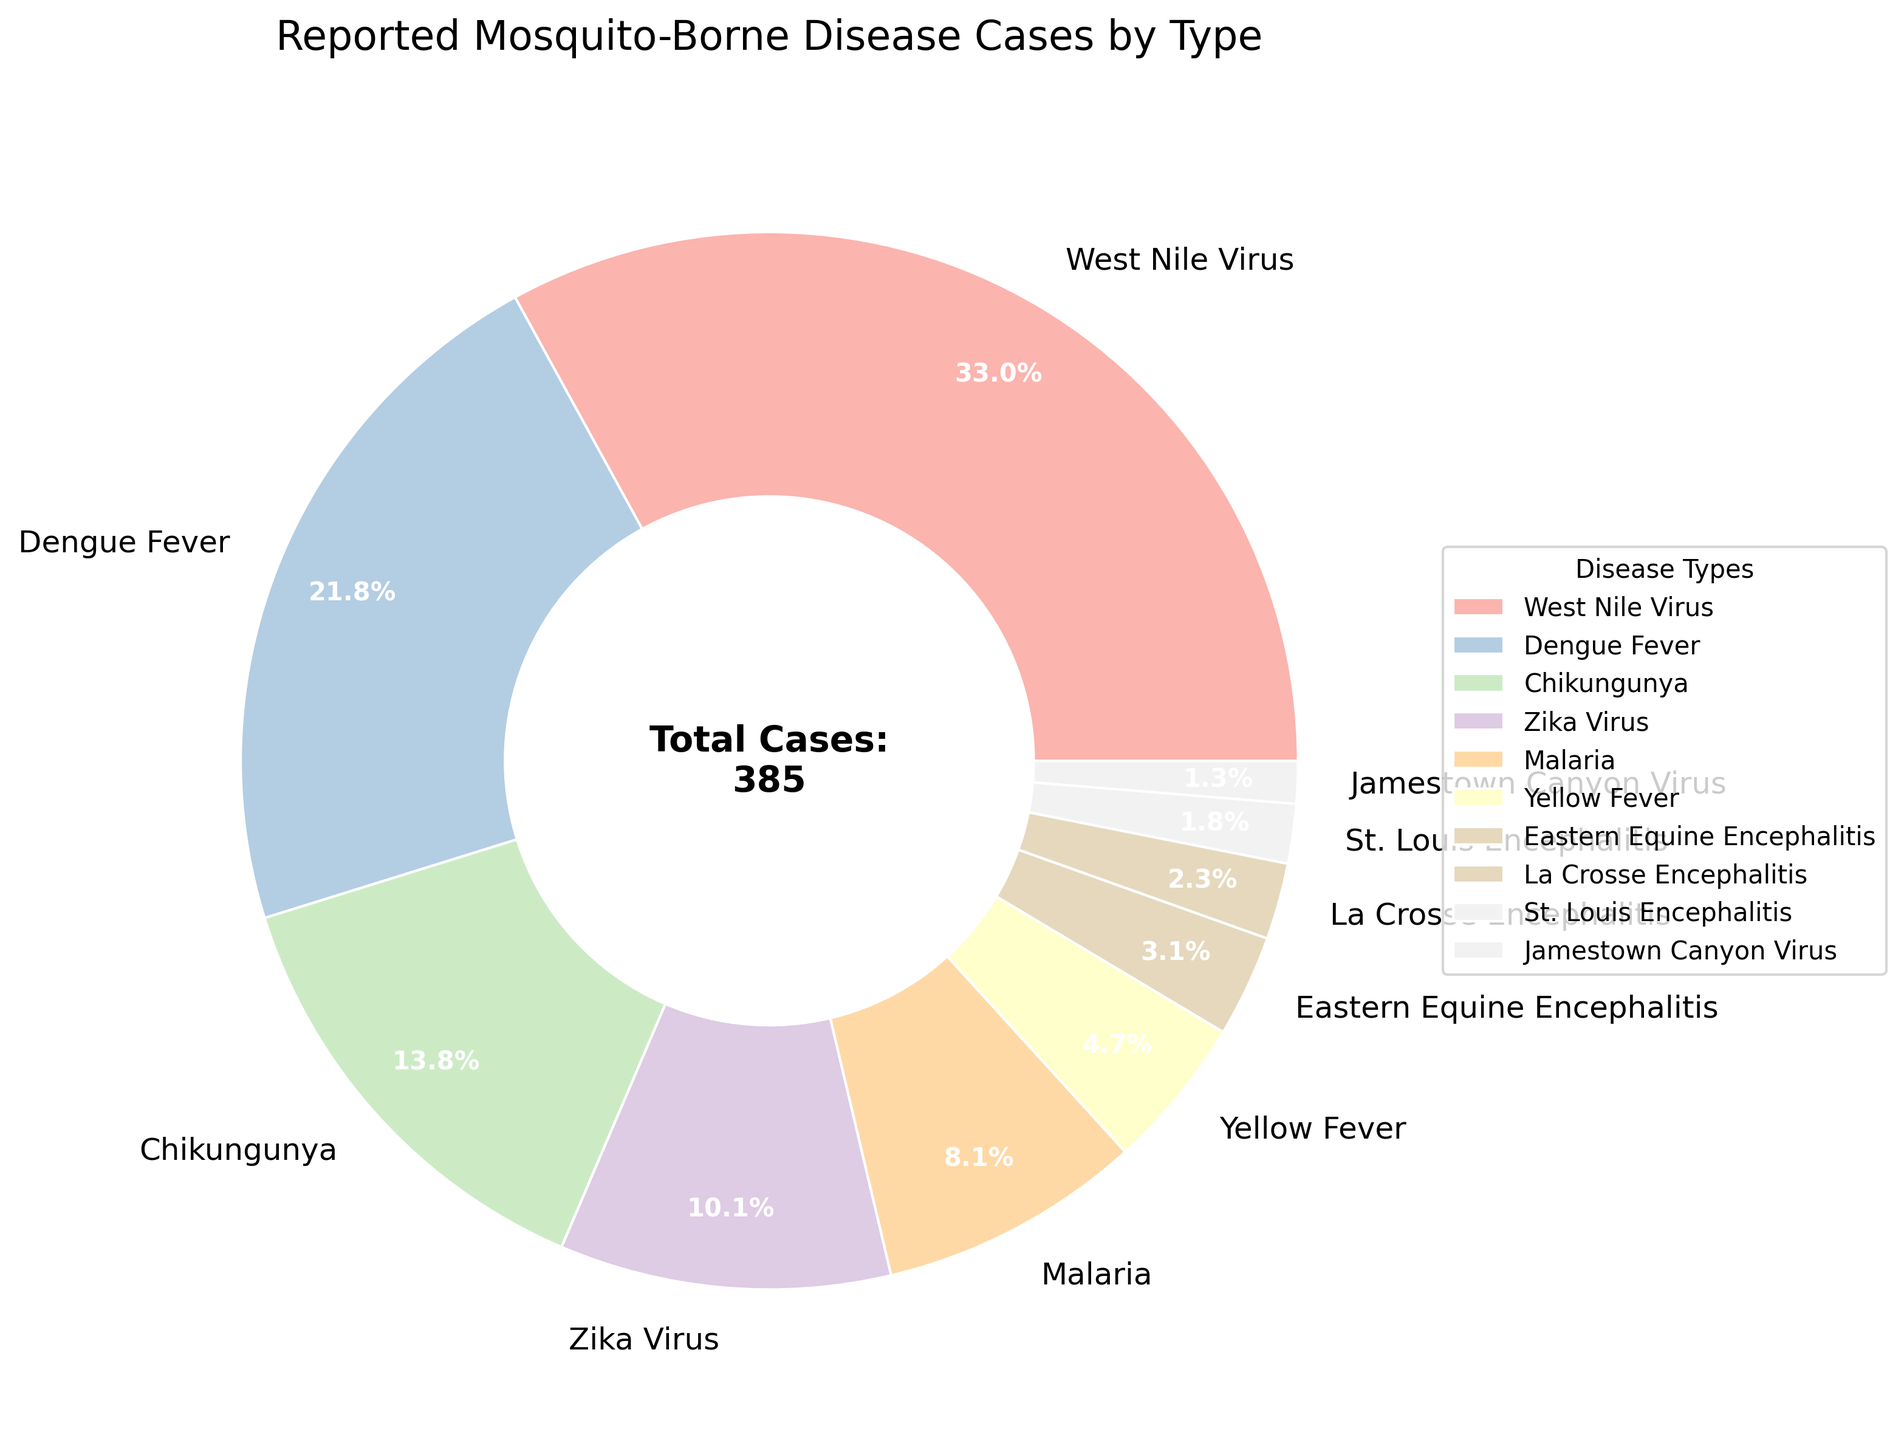What is the most reported mosquito-borne disease? From the pie chart, the largest wedge represents West Nile Virus. A text label and an auto-percentage text of 127 cases (32.6%) also confirm this.
Answer: West Nile Virus Which disease has the smallest number of reported cases? The smallest wedge in the pie chart is labeled Jamestown Canyon Virus with 5 cases (1.3%).
Answer: Jamestown Canyon Virus How many more cases does Dengue Fever have compared to Malaria? The pie chart shows 84 cases of Dengue Fever and 31 cases of Malaria. The difference is calculated by 84 - 31 = 53.
Answer: 53 What percentage of the total cases is represented by Zika Virus? The pie chart shows that Zika Virus represents 39 cases. The percentage provided in the pie chart is 10.0%.
Answer: 10.0% What is the total number of reported mosquito-borne disease cases? The pie chart includes the total number of cases (380) in the center. This is also the sum of all the cases: 127 + 84 + 53 + 39 + 31 + 18 + 12 + 9 + 7 + 5 = 385.
Answer: 385 Which disease has more reported cases, Chikungunya or Yellow Fever, and by how many? The pie chart shows 53 cases for Chikungunya and 18 for Yellow Fever. The difference is 53 - 18 = 35.
Answer: Chikungunya by 35 Are there more cases of Eastern Equine Encephalitis or St. Louis Encephalitis? The pie chart indicates 12 cases of Eastern Equine Encephalitis and 7 of St. Louis Encephalitis. Since 12 is greater than 7, there are more cases of Eastern Equine Encephalitis.
Answer: Eastern Equine Encephalitis What is the combined percentage of Malaria and Yellow Fever cases? According to the pie chart, Malaria has 31 cases (8.1%) and Yellow Fever has 18 cases (4.7%). Combined, this makes 12.8%.
Answer: 12.8% How many types of diseases have less than 20 reported cases? Observing the pie chart, there are 5 types (Yellow Fever, Eastern Equine Encephalitis, La Crosse Encephalitis, St. Louis Encephalitis, Jamestown Canyon Virus) with less than 20 cases each.
Answer: 5 Which diseases collectively account for more than 50% of the cases? From the pie chart, West Nile Virus (32.6%) and Dengue Fever (21.8%) together account for 54.4% of the total cases.
Answer: West Nile Virus and Dengue Fever 